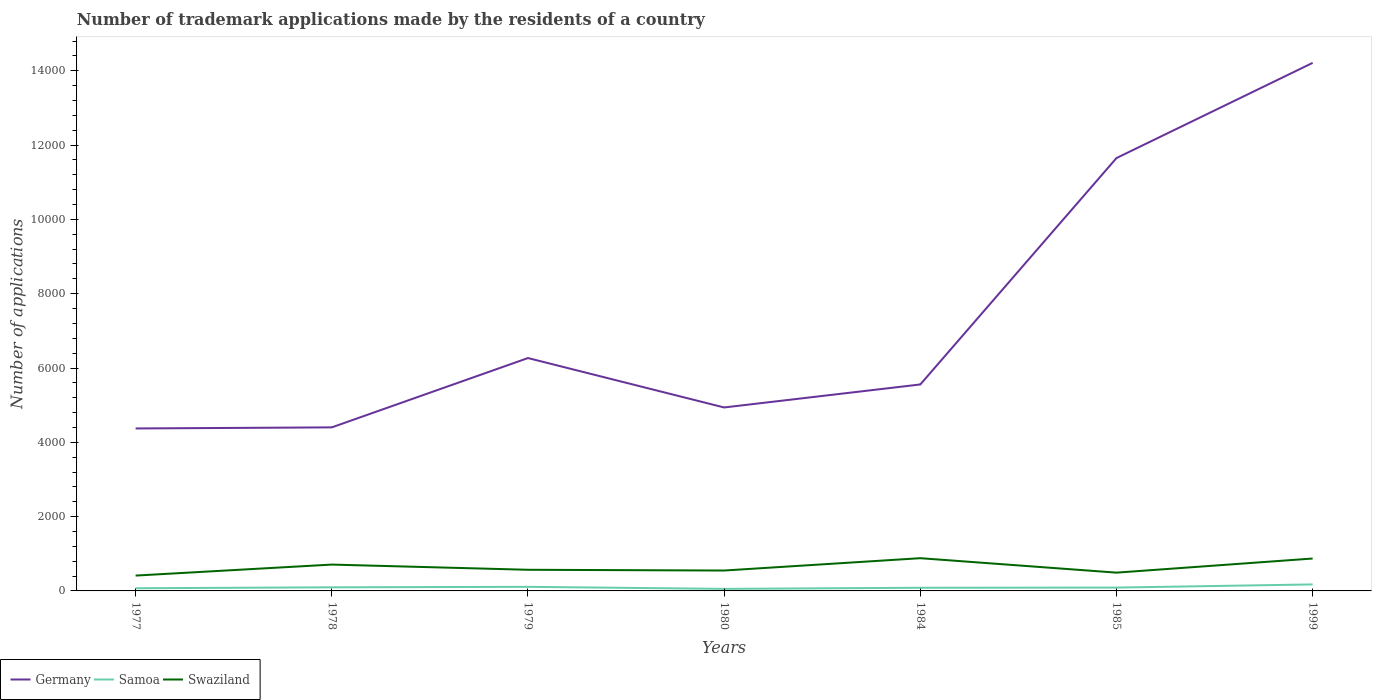Does the line corresponding to Germany intersect with the line corresponding to Samoa?
Your answer should be very brief. No. Is the number of lines equal to the number of legend labels?
Give a very brief answer. Yes. What is the difference between the highest and the second highest number of trademark applications made by the residents in Germany?
Your response must be concise. 9840. How many lines are there?
Your answer should be compact. 3. What is the difference between two consecutive major ticks on the Y-axis?
Your answer should be very brief. 2000. How are the legend labels stacked?
Provide a succinct answer. Horizontal. What is the title of the graph?
Your response must be concise. Number of trademark applications made by the residents of a country. What is the label or title of the X-axis?
Give a very brief answer. Years. What is the label or title of the Y-axis?
Offer a very short reply. Number of applications. What is the Number of applications of Germany in 1977?
Provide a succinct answer. 4373. What is the Number of applications of Samoa in 1977?
Give a very brief answer. 72. What is the Number of applications of Swaziland in 1977?
Offer a very short reply. 413. What is the Number of applications of Germany in 1978?
Provide a succinct answer. 4402. What is the Number of applications in Samoa in 1978?
Your response must be concise. 97. What is the Number of applications in Swaziland in 1978?
Offer a terse response. 709. What is the Number of applications in Germany in 1979?
Provide a short and direct response. 6268. What is the Number of applications of Samoa in 1979?
Ensure brevity in your answer.  110. What is the Number of applications in Swaziland in 1979?
Keep it short and to the point. 569. What is the Number of applications of Germany in 1980?
Offer a very short reply. 4938. What is the Number of applications of Samoa in 1980?
Offer a very short reply. 55. What is the Number of applications of Swaziland in 1980?
Keep it short and to the point. 549. What is the Number of applications of Germany in 1984?
Make the answer very short. 5557. What is the Number of applications in Samoa in 1984?
Provide a short and direct response. 85. What is the Number of applications in Swaziland in 1984?
Offer a very short reply. 881. What is the Number of applications in Germany in 1985?
Your response must be concise. 1.17e+04. What is the Number of applications in Samoa in 1985?
Offer a terse response. 90. What is the Number of applications in Swaziland in 1985?
Give a very brief answer. 492. What is the Number of applications in Germany in 1999?
Offer a very short reply. 1.42e+04. What is the Number of applications in Samoa in 1999?
Offer a very short reply. 175. What is the Number of applications of Swaziland in 1999?
Ensure brevity in your answer.  872. Across all years, what is the maximum Number of applications in Germany?
Ensure brevity in your answer.  1.42e+04. Across all years, what is the maximum Number of applications in Samoa?
Ensure brevity in your answer.  175. Across all years, what is the maximum Number of applications in Swaziland?
Your answer should be very brief. 881. Across all years, what is the minimum Number of applications in Germany?
Your answer should be very brief. 4373. Across all years, what is the minimum Number of applications in Samoa?
Your answer should be very brief. 55. Across all years, what is the minimum Number of applications in Swaziland?
Your answer should be compact. 413. What is the total Number of applications in Germany in the graph?
Provide a succinct answer. 5.14e+04. What is the total Number of applications of Samoa in the graph?
Offer a terse response. 684. What is the total Number of applications of Swaziland in the graph?
Provide a succinct answer. 4485. What is the difference between the Number of applications of Samoa in 1977 and that in 1978?
Provide a succinct answer. -25. What is the difference between the Number of applications of Swaziland in 1977 and that in 1978?
Your answer should be very brief. -296. What is the difference between the Number of applications in Germany in 1977 and that in 1979?
Your response must be concise. -1895. What is the difference between the Number of applications of Samoa in 1977 and that in 1979?
Provide a short and direct response. -38. What is the difference between the Number of applications of Swaziland in 1977 and that in 1979?
Offer a very short reply. -156. What is the difference between the Number of applications of Germany in 1977 and that in 1980?
Keep it short and to the point. -565. What is the difference between the Number of applications in Swaziland in 1977 and that in 1980?
Make the answer very short. -136. What is the difference between the Number of applications in Germany in 1977 and that in 1984?
Provide a short and direct response. -1184. What is the difference between the Number of applications of Swaziland in 1977 and that in 1984?
Your answer should be very brief. -468. What is the difference between the Number of applications of Germany in 1977 and that in 1985?
Offer a very short reply. -7278. What is the difference between the Number of applications of Samoa in 1977 and that in 1985?
Offer a terse response. -18. What is the difference between the Number of applications of Swaziland in 1977 and that in 1985?
Make the answer very short. -79. What is the difference between the Number of applications in Germany in 1977 and that in 1999?
Give a very brief answer. -9840. What is the difference between the Number of applications in Samoa in 1977 and that in 1999?
Provide a succinct answer. -103. What is the difference between the Number of applications in Swaziland in 1977 and that in 1999?
Make the answer very short. -459. What is the difference between the Number of applications in Germany in 1978 and that in 1979?
Your response must be concise. -1866. What is the difference between the Number of applications in Samoa in 1978 and that in 1979?
Give a very brief answer. -13. What is the difference between the Number of applications of Swaziland in 1978 and that in 1979?
Your response must be concise. 140. What is the difference between the Number of applications in Germany in 1978 and that in 1980?
Offer a terse response. -536. What is the difference between the Number of applications of Samoa in 1978 and that in 1980?
Your answer should be very brief. 42. What is the difference between the Number of applications of Swaziland in 1978 and that in 1980?
Offer a very short reply. 160. What is the difference between the Number of applications in Germany in 1978 and that in 1984?
Your response must be concise. -1155. What is the difference between the Number of applications in Samoa in 1978 and that in 1984?
Provide a succinct answer. 12. What is the difference between the Number of applications of Swaziland in 1978 and that in 1984?
Give a very brief answer. -172. What is the difference between the Number of applications of Germany in 1978 and that in 1985?
Your answer should be compact. -7249. What is the difference between the Number of applications in Swaziland in 1978 and that in 1985?
Make the answer very short. 217. What is the difference between the Number of applications in Germany in 1978 and that in 1999?
Your response must be concise. -9811. What is the difference between the Number of applications of Samoa in 1978 and that in 1999?
Provide a short and direct response. -78. What is the difference between the Number of applications in Swaziland in 1978 and that in 1999?
Offer a very short reply. -163. What is the difference between the Number of applications in Germany in 1979 and that in 1980?
Your answer should be very brief. 1330. What is the difference between the Number of applications in Samoa in 1979 and that in 1980?
Make the answer very short. 55. What is the difference between the Number of applications in Swaziland in 1979 and that in 1980?
Offer a terse response. 20. What is the difference between the Number of applications of Germany in 1979 and that in 1984?
Provide a succinct answer. 711. What is the difference between the Number of applications of Swaziland in 1979 and that in 1984?
Offer a very short reply. -312. What is the difference between the Number of applications in Germany in 1979 and that in 1985?
Give a very brief answer. -5383. What is the difference between the Number of applications of Samoa in 1979 and that in 1985?
Offer a very short reply. 20. What is the difference between the Number of applications in Germany in 1979 and that in 1999?
Provide a succinct answer. -7945. What is the difference between the Number of applications in Samoa in 1979 and that in 1999?
Your response must be concise. -65. What is the difference between the Number of applications in Swaziland in 1979 and that in 1999?
Your answer should be compact. -303. What is the difference between the Number of applications of Germany in 1980 and that in 1984?
Make the answer very short. -619. What is the difference between the Number of applications in Samoa in 1980 and that in 1984?
Provide a succinct answer. -30. What is the difference between the Number of applications in Swaziland in 1980 and that in 1984?
Your answer should be very brief. -332. What is the difference between the Number of applications of Germany in 1980 and that in 1985?
Your answer should be very brief. -6713. What is the difference between the Number of applications in Samoa in 1980 and that in 1985?
Keep it short and to the point. -35. What is the difference between the Number of applications in Swaziland in 1980 and that in 1985?
Your answer should be compact. 57. What is the difference between the Number of applications of Germany in 1980 and that in 1999?
Offer a terse response. -9275. What is the difference between the Number of applications in Samoa in 1980 and that in 1999?
Keep it short and to the point. -120. What is the difference between the Number of applications of Swaziland in 1980 and that in 1999?
Your answer should be very brief. -323. What is the difference between the Number of applications of Germany in 1984 and that in 1985?
Your answer should be very brief. -6094. What is the difference between the Number of applications of Swaziland in 1984 and that in 1985?
Give a very brief answer. 389. What is the difference between the Number of applications in Germany in 1984 and that in 1999?
Keep it short and to the point. -8656. What is the difference between the Number of applications in Samoa in 1984 and that in 1999?
Keep it short and to the point. -90. What is the difference between the Number of applications in Germany in 1985 and that in 1999?
Your answer should be compact. -2562. What is the difference between the Number of applications of Samoa in 1985 and that in 1999?
Offer a terse response. -85. What is the difference between the Number of applications in Swaziland in 1985 and that in 1999?
Your response must be concise. -380. What is the difference between the Number of applications of Germany in 1977 and the Number of applications of Samoa in 1978?
Provide a short and direct response. 4276. What is the difference between the Number of applications of Germany in 1977 and the Number of applications of Swaziland in 1978?
Your answer should be compact. 3664. What is the difference between the Number of applications in Samoa in 1977 and the Number of applications in Swaziland in 1978?
Your response must be concise. -637. What is the difference between the Number of applications in Germany in 1977 and the Number of applications in Samoa in 1979?
Give a very brief answer. 4263. What is the difference between the Number of applications of Germany in 1977 and the Number of applications of Swaziland in 1979?
Provide a short and direct response. 3804. What is the difference between the Number of applications in Samoa in 1977 and the Number of applications in Swaziland in 1979?
Your answer should be compact. -497. What is the difference between the Number of applications of Germany in 1977 and the Number of applications of Samoa in 1980?
Your response must be concise. 4318. What is the difference between the Number of applications of Germany in 1977 and the Number of applications of Swaziland in 1980?
Ensure brevity in your answer.  3824. What is the difference between the Number of applications in Samoa in 1977 and the Number of applications in Swaziland in 1980?
Your answer should be compact. -477. What is the difference between the Number of applications of Germany in 1977 and the Number of applications of Samoa in 1984?
Ensure brevity in your answer.  4288. What is the difference between the Number of applications in Germany in 1977 and the Number of applications in Swaziland in 1984?
Offer a very short reply. 3492. What is the difference between the Number of applications of Samoa in 1977 and the Number of applications of Swaziland in 1984?
Your answer should be compact. -809. What is the difference between the Number of applications in Germany in 1977 and the Number of applications in Samoa in 1985?
Your answer should be compact. 4283. What is the difference between the Number of applications of Germany in 1977 and the Number of applications of Swaziland in 1985?
Ensure brevity in your answer.  3881. What is the difference between the Number of applications in Samoa in 1977 and the Number of applications in Swaziland in 1985?
Provide a succinct answer. -420. What is the difference between the Number of applications of Germany in 1977 and the Number of applications of Samoa in 1999?
Ensure brevity in your answer.  4198. What is the difference between the Number of applications of Germany in 1977 and the Number of applications of Swaziland in 1999?
Offer a terse response. 3501. What is the difference between the Number of applications in Samoa in 1977 and the Number of applications in Swaziland in 1999?
Your answer should be compact. -800. What is the difference between the Number of applications of Germany in 1978 and the Number of applications of Samoa in 1979?
Provide a succinct answer. 4292. What is the difference between the Number of applications in Germany in 1978 and the Number of applications in Swaziland in 1979?
Ensure brevity in your answer.  3833. What is the difference between the Number of applications of Samoa in 1978 and the Number of applications of Swaziland in 1979?
Your response must be concise. -472. What is the difference between the Number of applications of Germany in 1978 and the Number of applications of Samoa in 1980?
Make the answer very short. 4347. What is the difference between the Number of applications in Germany in 1978 and the Number of applications in Swaziland in 1980?
Ensure brevity in your answer.  3853. What is the difference between the Number of applications in Samoa in 1978 and the Number of applications in Swaziland in 1980?
Your answer should be compact. -452. What is the difference between the Number of applications in Germany in 1978 and the Number of applications in Samoa in 1984?
Ensure brevity in your answer.  4317. What is the difference between the Number of applications in Germany in 1978 and the Number of applications in Swaziland in 1984?
Keep it short and to the point. 3521. What is the difference between the Number of applications of Samoa in 1978 and the Number of applications of Swaziland in 1984?
Keep it short and to the point. -784. What is the difference between the Number of applications of Germany in 1978 and the Number of applications of Samoa in 1985?
Keep it short and to the point. 4312. What is the difference between the Number of applications of Germany in 1978 and the Number of applications of Swaziland in 1985?
Keep it short and to the point. 3910. What is the difference between the Number of applications of Samoa in 1978 and the Number of applications of Swaziland in 1985?
Ensure brevity in your answer.  -395. What is the difference between the Number of applications of Germany in 1978 and the Number of applications of Samoa in 1999?
Make the answer very short. 4227. What is the difference between the Number of applications of Germany in 1978 and the Number of applications of Swaziland in 1999?
Make the answer very short. 3530. What is the difference between the Number of applications in Samoa in 1978 and the Number of applications in Swaziland in 1999?
Offer a terse response. -775. What is the difference between the Number of applications in Germany in 1979 and the Number of applications in Samoa in 1980?
Your answer should be very brief. 6213. What is the difference between the Number of applications of Germany in 1979 and the Number of applications of Swaziland in 1980?
Provide a short and direct response. 5719. What is the difference between the Number of applications in Samoa in 1979 and the Number of applications in Swaziland in 1980?
Provide a succinct answer. -439. What is the difference between the Number of applications in Germany in 1979 and the Number of applications in Samoa in 1984?
Provide a short and direct response. 6183. What is the difference between the Number of applications in Germany in 1979 and the Number of applications in Swaziland in 1984?
Provide a succinct answer. 5387. What is the difference between the Number of applications in Samoa in 1979 and the Number of applications in Swaziland in 1984?
Ensure brevity in your answer.  -771. What is the difference between the Number of applications in Germany in 1979 and the Number of applications in Samoa in 1985?
Keep it short and to the point. 6178. What is the difference between the Number of applications of Germany in 1979 and the Number of applications of Swaziland in 1985?
Keep it short and to the point. 5776. What is the difference between the Number of applications of Samoa in 1979 and the Number of applications of Swaziland in 1985?
Your answer should be compact. -382. What is the difference between the Number of applications in Germany in 1979 and the Number of applications in Samoa in 1999?
Provide a short and direct response. 6093. What is the difference between the Number of applications of Germany in 1979 and the Number of applications of Swaziland in 1999?
Give a very brief answer. 5396. What is the difference between the Number of applications in Samoa in 1979 and the Number of applications in Swaziland in 1999?
Your answer should be compact. -762. What is the difference between the Number of applications in Germany in 1980 and the Number of applications in Samoa in 1984?
Provide a short and direct response. 4853. What is the difference between the Number of applications in Germany in 1980 and the Number of applications in Swaziland in 1984?
Make the answer very short. 4057. What is the difference between the Number of applications in Samoa in 1980 and the Number of applications in Swaziland in 1984?
Provide a short and direct response. -826. What is the difference between the Number of applications in Germany in 1980 and the Number of applications in Samoa in 1985?
Your answer should be compact. 4848. What is the difference between the Number of applications in Germany in 1980 and the Number of applications in Swaziland in 1985?
Give a very brief answer. 4446. What is the difference between the Number of applications in Samoa in 1980 and the Number of applications in Swaziland in 1985?
Your response must be concise. -437. What is the difference between the Number of applications in Germany in 1980 and the Number of applications in Samoa in 1999?
Keep it short and to the point. 4763. What is the difference between the Number of applications of Germany in 1980 and the Number of applications of Swaziland in 1999?
Your response must be concise. 4066. What is the difference between the Number of applications of Samoa in 1980 and the Number of applications of Swaziland in 1999?
Your response must be concise. -817. What is the difference between the Number of applications in Germany in 1984 and the Number of applications in Samoa in 1985?
Keep it short and to the point. 5467. What is the difference between the Number of applications of Germany in 1984 and the Number of applications of Swaziland in 1985?
Keep it short and to the point. 5065. What is the difference between the Number of applications in Samoa in 1984 and the Number of applications in Swaziland in 1985?
Provide a succinct answer. -407. What is the difference between the Number of applications in Germany in 1984 and the Number of applications in Samoa in 1999?
Offer a very short reply. 5382. What is the difference between the Number of applications in Germany in 1984 and the Number of applications in Swaziland in 1999?
Your answer should be very brief. 4685. What is the difference between the Number of applications of Samoa in 1984 and the Number of applications of Swaziland in 1999?
Provide a short and direct response. -787. What is the difference between the Number of applications of Germany in 1985 and the Number of applications of Samoa in 1999?
Your answer should be very brief. 1.15e+04. What is the difference between the Number of applications in Germany in 1985 and the Number of applications in Swaziland in 1999?
Your answer should be compact. 1.08e+04. What is the difference between the Number of applications of Samoa in 1985 and the Number of applications of Swaziland in 1999?
Your response must be concise. -782. What is the average Number of applications in Germany per year?
Your response must be concise. 7343.14. What is the average Number of applications in Samoa per year?
Your answer should be very brief. 97.71. What is the average Number of applications in Swaziland per year?
Keep it short and to the point. 640.71. In the year 1977, what is the difference between the Number of applications of Germany and Number of applications of Samoa?
Provide a succinct answer. 4301. In the year 1977, what is the difference between the Number of applications in Germany and Number of applications in Swaziland?
Offer a very short reply. 3960. In the year 1977, what is the difference between the Number of applications in Samoa and Number of applications in Swaziland?
Give a very brief answer. -341. In the year 1978, what is the difference between the Number of applications in Germany and Number of applications in Samoa?
Give a very brief answer. 4305. In the year 1978, what is the difference between the Number of applications of Germany and Number of applications of Swaziland?
Make the answer very short. 3693. In the year 1978, what is the difference between the Number of applications in Samoa and Number of applications in Swaziland?
Your response must be concise. -612. In the year 1979, what is the difference between the Number of applications of Germany and Number of applications of Samoa?
Your answer should be compact. 6158. In the year 1979, what is the difference between the Number of applications of Germany and Number of applications of Swaziland?
Provide a succinct answer. 5699. In the year 1979, what is the difference between the Number of applications in Samoa and Number of applications in Swaziland?
Give a very brief answer. -459. In the year 1980, what is the difference between the Number of applications in Germany and Number of applications in Samoa?
Make the answer very short. 4883. In the year 1980, what is the difference between the Number of applications of Germany and Number of applications of Swaziland?
Your answer should be very brief. 4389. In the year 1980, what is the difference between the Number of applications of Samoa and Number of applications of Swaziland?
Provide a short and direct response. -494. In the year 1984, what is the difference between the Number of applications of Germany and Number of applications of Samoa?
Your answer should be compact. 5472. In the year 1984, what is the difference between the Number of applications in Germany and Number of applications in Swaziland?
Ensure brevity in your answer.  4676. In the year 1984, what is the difference between the Number of applications of Samoa and Number of applications of Swaziland?
Provide a short and direct response. -796. In the year 1985, what is the difference between the Number of applications of Germany and Number of applications of Samoa?
Provide a short and direct response. 1.16e+04. In the year 1985, what is the difference between the Number of applications in Germany and Number of applications in Swaziland?
Your response must be concise. 1.12e+04. In the year 1985, what is the difference between the Number of applications of Samoa and Number of applications of Swaziland?
Ensure brevity in your answer.  -402. In the year 1999, what is the difference between the Number of applications in Germany and Number of applications in Samoa?
Offer a very short reply. 1.40e+04. In the year 1999, what is the difference between the Number of applications in Germany and Number of applications in Swaziland?
Your response must be concise. 1.33e+04. In the year 1999, what is the difference between the Number of applications of Samoa and Number of applications of Swaziland?
Offer a very short reply. -697. What is the ratio of the Number of applications in Germany in 1977 to that in 1978?
Make the answer very short. 0.99. What is the ratio of the Number of applications in Samoa in 1977 to that in 1978?
Provide a succinct answer. 0.74. What is the ratio of the Number of applications of Swaziland in 1977 to that in 1978?
Your answer should be very brief. 0.58. What is the ratio of the Number of applications of Germany in 1977 to that in 1979?
Keep it short and to the point. 0.7. What is the ratio of the Number of applications of Samoa in 1977 to that in 1979?
Your answer should be very brief. 0.65. What is the ratio of the Number of applications in Swaziland in 1977 to that in 1979?
Your answer should be very brief. 0.73. What is the ratio of the Number of applications in Germany in 1977 to that in 1980?
Give a very brief answer. 0.89. What is the ratio of the Number of applications in Samoa in 1977 to that in 1980?
Provide a succinct answer. 1.31. What is the ratio of the Number of applications of Swaziland in 1977 to that in 1980?
Your answer should be very brief. 0.75. What is the ratio of the Number of applications in Germany in 1977 to that in 1984?
Your answer should be very brief. 0.79. What is the ratio of the Number of applications of Samoa in 1977 to that in 1984?
Ensure brevity in your answer.  0.85. What is the ratio of the Number of applications of Swaziland in 1977 to that in 1984?
Ensure brevity in your answer.  0.47. What is the ratio of the Number of applications of Germany in 1977 to that in 1985?
Ensure brevity in your answer.  0.38. What is the ratio of the Number of applications of Samoa in 1977 to that in 1985?
Your answer should be very brief. 0.8. What is the ratio of the Number of applications of Swaziland in 1977 to that in 1985?
Provide a succinct answer. 0.84. What is the ratio of the Number of applications in Germany in 1977 to that in 1999?
Offer a very short reply. 0.31. What is the ratio of the Number of applications of Samoa in 1977 to that in 1999?
Offer a terse response. 0.41. What is the ratio of the Number of applications of Swaziland in 1977 to that in 1999?
Your answer should be compact. 0.47. What is the ratio of the Number of applications in Germany in 1978 to that in 1979?
Offer a very short reply. 0.7. What is the ratio of the Number of applications of Samoa in 1978 to that in 1979?
Your response must be concise. 0.88. What is the ratio of the Number of applications of Swaziland in 1978 to that in 1979?
Your answer should be compact. 1.25. What is the ratio of the Number of applications of Germany in 1978 to that in 1980?
Your response must be concise. 0.89. What is the ratio of the Number of applications in Samoa in 1978 to that in 1980?
Offer a terse response. 1.76. What is the ratio of the Number of applications of Swaziland in 1978 to that in 1980?
Your answer should be very brief. 1.29. What is the ratio of the Number of applications in Germany in 1978 to that in 1984?
Make the answer very short. 0.79. What is the ratio of the Number of applications in Samoa in 1978 to that in 1984?
Your response must be concise. 1.14. What is the ratio of the Number of applications in Swaziland in 1978 to that in 1984?
Give a very brief answer. 0.8. What is the ratio of the Number of applications in Germany in 1978 to that in 1985?
Make the answer very short. 0.38. What is the ratio of the Number of applications in Samoa in 1978 to that in 1985?
Your answer should be very brief. 1.08. What is the ratio of the Number of applications in Swaziland in 1978 to that in 1985?
Ensure brevity in your answer.  1.44. What is the ratio of the Number of applications of Germany in 1978 to that in 1999?
Your answer should be compact. 0.31. What is the ratio of the Number of applications in Samoa in 1978 to that in 1999?
Offer a terse response. 0.55. What is the ratio of the Number of applications in Swaziland in 1978 to that in 1999?
Your answer should be compact. 0.81. What is the ratio of the Number of applications in Germany in 1979 to that in 1980?
Offer a terse response. 1.27. What is the ratio of the Number of applications in Swaziland in 1979 to that in 1980?
Offer a very short reply. 1.04. What is the ratio of the Number of applications in Germany in 1979 to that in 1984?
Give a very brief answer. 1.13. What is the ratio of the Number of applications of Samoa in 1979 to that in 1984?
Your response must be concise. 1.29. What is the ratio of the Number of applications of Swaziland in 1979 to that in 1984?
Give a very brief answer. 0.65. What is the ratio of the Number of applications of Germany in 1979 to that in 1985?
Give a very brief answer. 0.54. What is the ratio of the Number of applications of Samoa in 1979 to that in 1985?
Give a very brief answer. 1.22. What is the ratio of the Number of applications of Swaziland in 1979 to that in 1985?
Your response must be concise. 1.16. What is the ratio of the Number of applications in Germany in 1979 to that in 1999?
Your answer should be very brief. 0.44. What is the ratio of the Number of applications in Samoa in 1979 to that in 1999?
Provide a short and direct response. 0.63. What is the ratio of the Number of applications of Swaziland in 1979 to that in 1999?
Keep it short and to the point. 0.65. What is the ratio of the Number of applications in Germany in 1980 to that in 1984?
Provide a succinct answer. 0.89. What is the ratio of the Number of applications of Samoa in 1980 to that in 1984?
Give a very brief answer. 0.65. What is the ratio of the Number of applications in Swaziland in 1980 to that in 1984?
Your response must be concise. 0.62. What is the ratio of the Number of applications in Germany in 1980 to that in 1985?
Ensure brevity in your answer.  0.42. What is the ratio of the Number of applications of Samoa in 1980 to that in 1985?
Offer a terse response. 0.61. What is the ratio of the Number of applications in Swaziland in 1980 to that in 1985?
Offer a terse response. 1.12. What is the ratio of the Number of applications of Germany in 1980 to that in 1999?
Offer a terse response. 0.35. What is the ratio of the Number of applications of Samoa in 1980 to that in 1999?
Offer a very short reply. 0.31. What is the ratio of the Number of applications in Swaziland in 1980 to that in 1999?
Give a very brief answer. 0.63. What is the ratio of the Number of applications in Germany in 1984 to that in 1985?
Your answer should be compact. 0.48. What is the ratio of the Number of applications of Swaziland in 1984 to that in 1985?
Offer a terse response. 1.79. What is the ratio of the Number of applications of Germany in 1984 to that in 1999?
Provide a succinct answer. 0.39. What is the ratio of the Number of applications in Samoa in 1984 to that in 1999?
Your answer should be very brief. 0.49. What is the ratio of the Number of applications in Swaziland in 1984 to that in 1999?
Offer a very short reply. 1.01. What is the ratio of the Number of applications in Germany in 1985 to that in 1999?
Provide a succinct answer. 0.82. What is the ratio of the Number of applications in Samoa in 1985 to that in 1999?
Make the answer very short. 0.51. What is the ratio of the Number of applications in Swaziland in 1985 to that in 1999?
Provide a succinct answer. 0.56. What is the difference between the highest and the second highest Number of applications in Germany?
Ensure brevity in your answer.  2562. What is the difference between the highest and the second highest Number of applications in Samoa?
Make the answer very short. 65. What is the difference between the highest and the lowest Number of applications of Germany?
Provide a succinct answer. 9840. What is the difference between the highest and the lowest Number of applications of Samoa?
Provide a short and direct response. 120. What is the difference between the highest and the lowest Number of applications in Swaziland?
Your answer should be very brief. 468. 